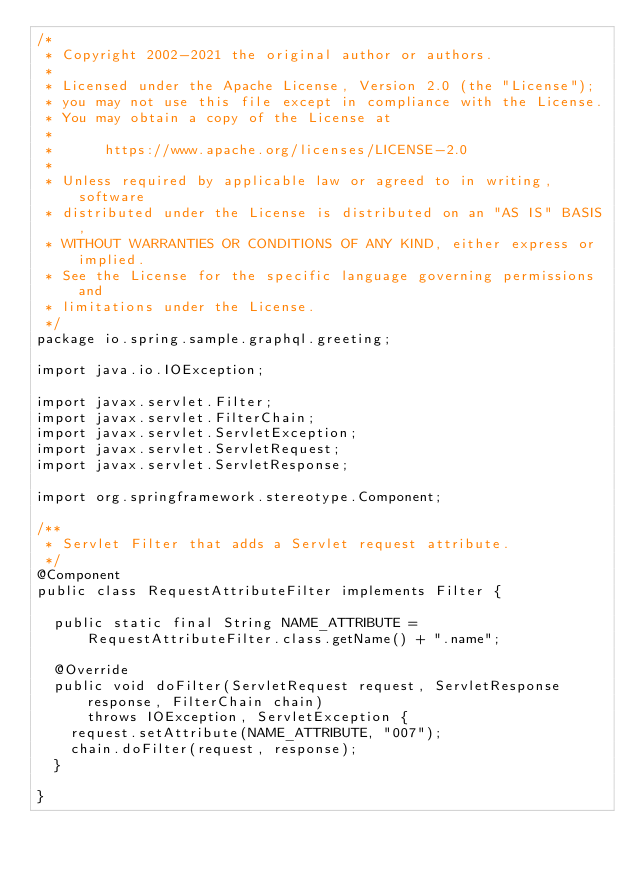Convert code to text. <code><loc_0><loc_0><loc_500><loc_500><_Java_>/*
 * Copyright 2002-2021 the original author or authors.
 *
 * Licensed under the Apache License, Version 2.0 (the "License");
 * you may not use this file except in compliance with the License.
 * You may obtain a copy of the License at
 *
 *      https://www.apache.org/licenses/LICENSE-2.0
 *
 * Unless required by applicable law or agreed to in writing, software
 * distributed under the License is distributed on an "AS IS" BASIS,
 * WITHOUT WARRANTIES OR CONDITIONS OF ANY KIND, either express or implied.
 * See the License for the specific language governing permissions and
 * limitations under the License.
 */
package io.spring.sample.graphql.greeting;

import java.io.IOException;

import javax.servlet.Filter;
import javax.servlet.FilterChain;
import javax.servlet.ServletException;
import javax.servlet.ServletRequest;
import javax.servlet.ServletResponse;

import org.springframework.stereotype.Component;

/**
 * Servlet Filter that adds a Servlet request attribute.
 */
@Component
public class RequestAttributeFilter implements Filter {

	public static final String NAME_ATTRIBUTE = RequestAttributeFilter.class.getName() + ".name";

	@Override
	public void doFilter(ServletRequest request, ServletResponse response, FilterChain chain)
			throws IOException, ServletException {
		request.setAttribute(NAME_ATTRIBUTE, "007");
		chain.doFilter(request, response);
	}

}
</code> 